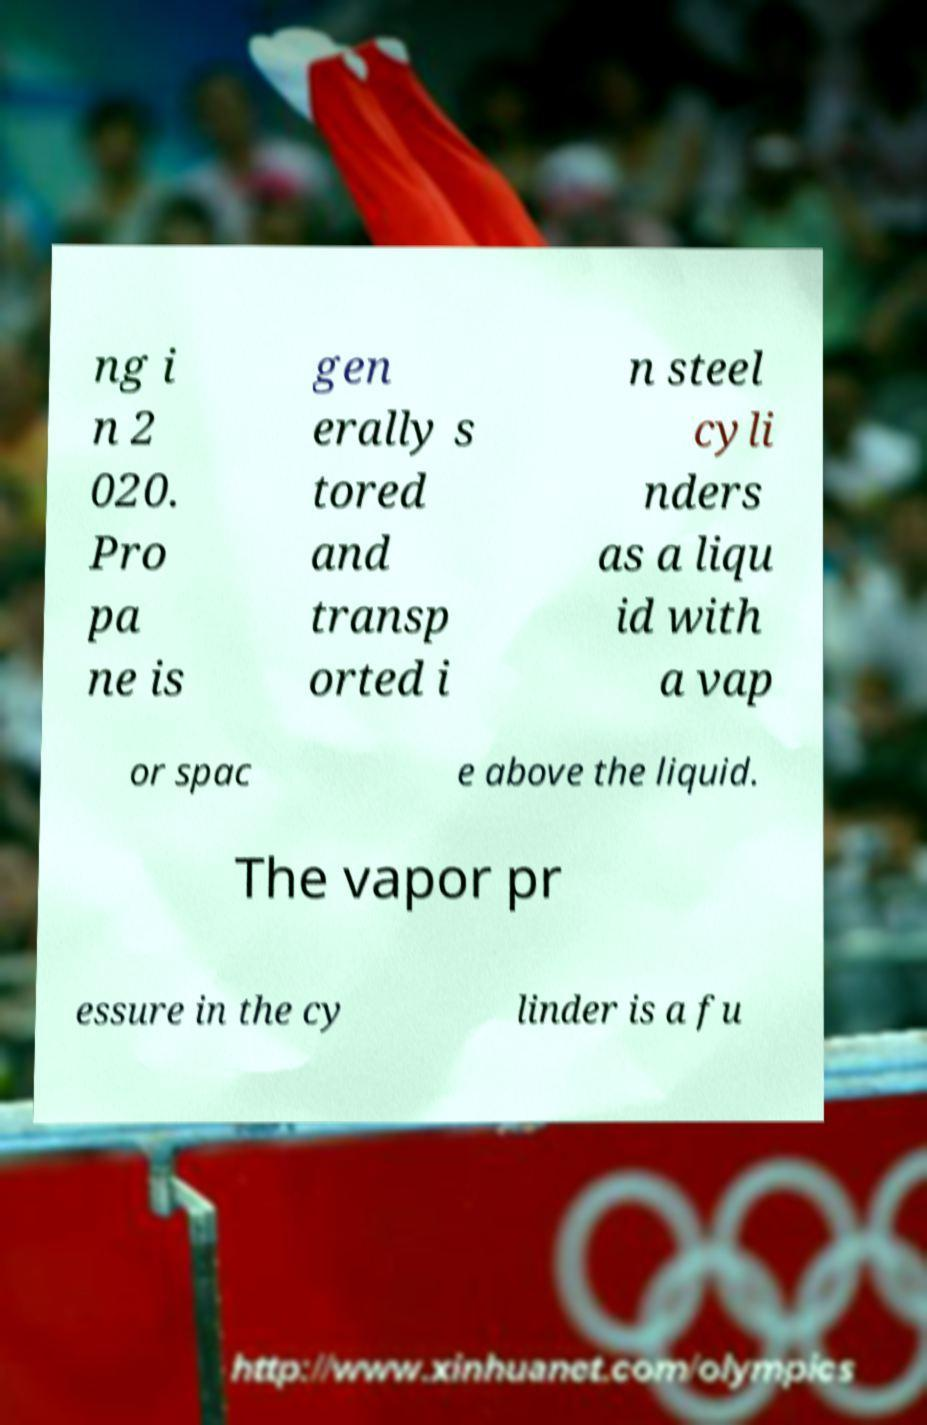Can you accurately transcribe the text from the provided image for me? ng i n 2 020. Pro pa ne is gen erally s tored and transp orted i n steel cyli nders as a liqu id with a vap or spac e above the liquid. The vapor pr essure in the cy linder is a fu 